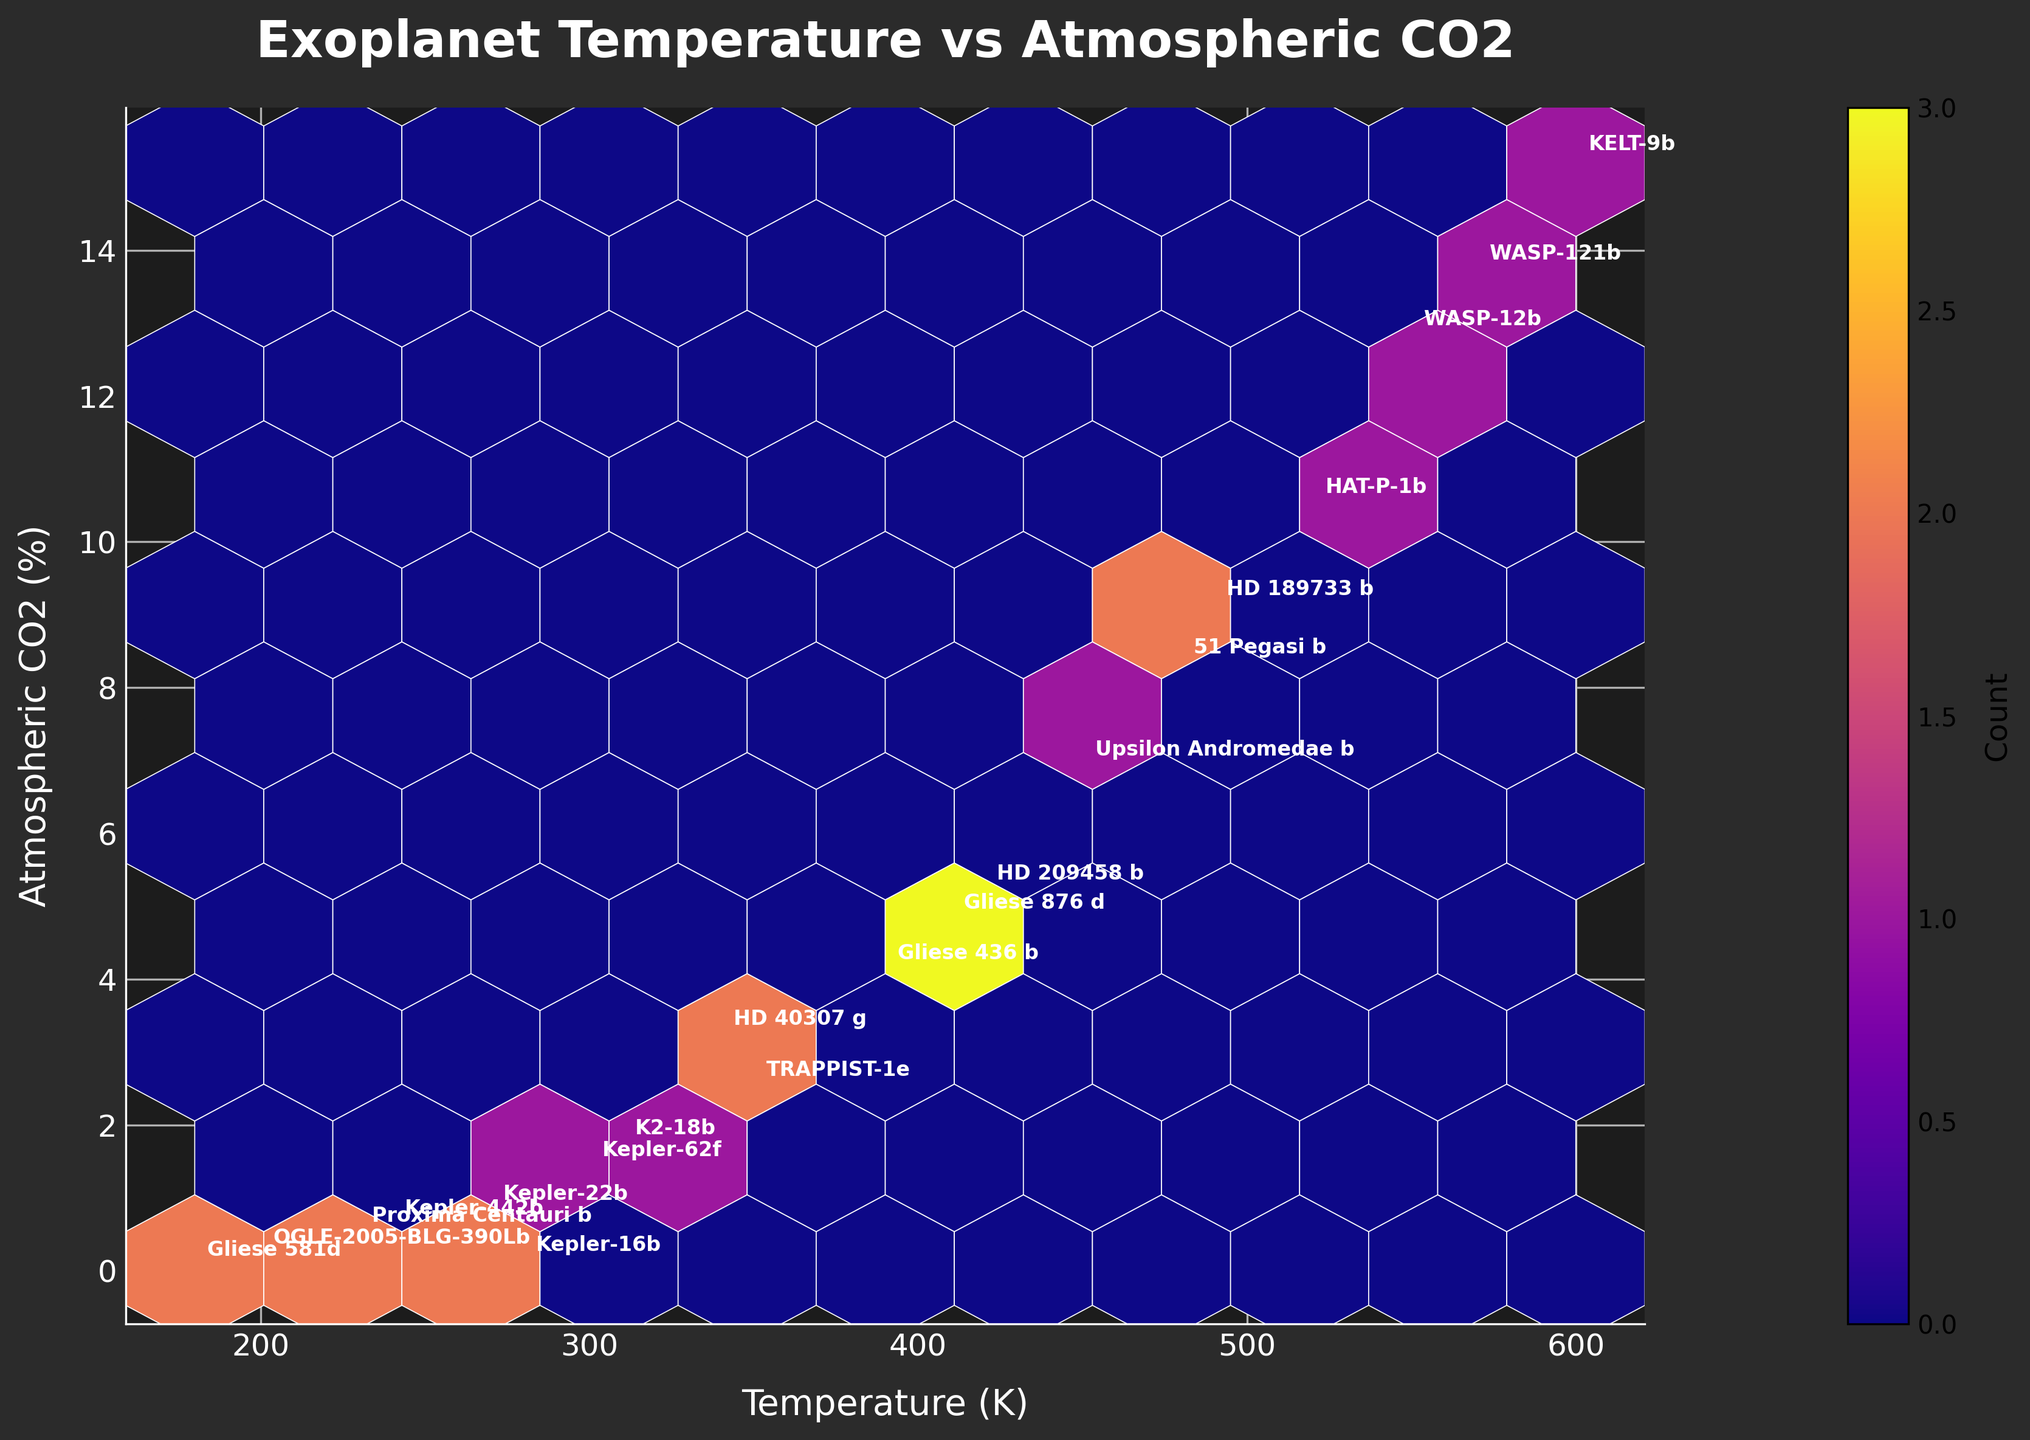What is the title of the plot? The title of the plot can be found at the top of the figure and it reads "Exoplanet Temperature vs Atmospheric CO2".
Answer: Exoplanet Temperature vs Atmospheric CO2 What is the color scheme used in the hexbin plot? The color scheme of the hexbin plot can be observed from the color gradient in the hexagons. The plot uses the 'plasma' colormap, which typically ranges from dark purple to yellow.
Answer: Plasma colormap How many data points are there in the dataset? By counting the number of labels each planet name in the hexbin plot, you can determine the number of data points. Each label represents one data point. There are 20 planet names representing 20 data points in total.
Answer: 20 Which planet has the highest temperature? Locate the label next to the highest value on the temperature (x) axis, which is KELT-9b at 600 K.
Answer: KELT-9b What's the average atmospheric CO2 (%) for the planets with temperatures above 500 K? First, identify planets with temperatures above 500 K: WASP-12b (12.8%), HAT-P-1b (10.5%), WASP-121b (13.7%), and KELT-9b (15.2%). Then, calculate the average: (12.8 + 10.5 + 13.7 + 15.2) / 4 = 13.05.
Answer: 13.05% How does the temperature of TRAPPIST-1e compare to that of K2-18b? Compare the temperature values of TRAPPIST-1e (350 K) and K2-18b (310 K). Hence, TRAPPIST-1e has a higher temperature than K2-18b.
Answer: TRAPPIST-1e has a higher temperature What is the total count of planets with an atmospheric CO2 greater than 10%? Identify the planets with atmospheric CO2 greater than 10%: WASP-12b, HAT-P-1b, WASP-121b, and KELT-9b. There are 4 in total.
Answer: 4 Which planet is an outlier with the lowest atmospheric CO2 and also a low temperature? Observe the planet with the lowest point in the y-axis (Atmospheric CO2) while also having a relatively low temperature. Gliese 581d has the lowest CO2 at 0.03%.
Answer: Gliese 581d How densely packed are the data points with temperatures between 200 K to 300 K? Look at the density of hexagons between 200 K and 300 K on the x-axis. Most of the hexagons in this range appear less densely packed.
Answer: Less densely packed What does the color coding indicate in the hexbin plot? The color coding, represented by a color bar, indicates the count of data points within each hexagon; brighter colors represent higher counts.
Answer: Count of data points 